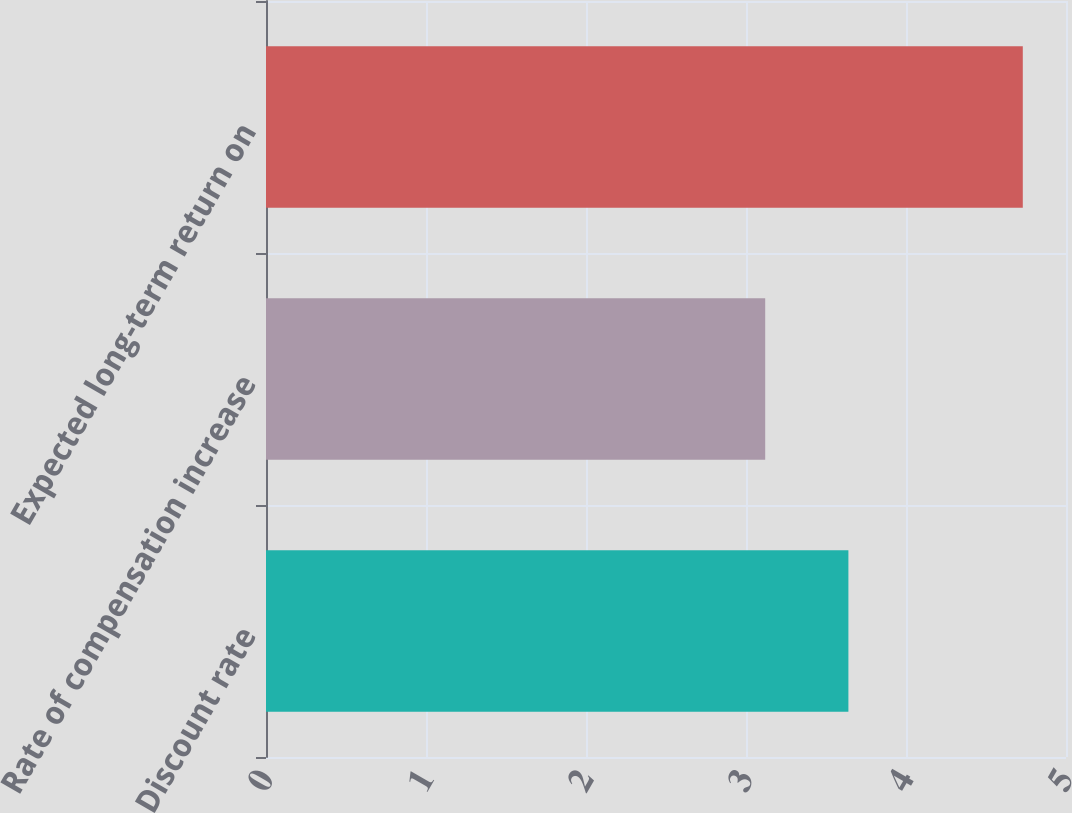<chart> <loc_0><loc_0><loc_500><loc_500><bar_chart><fcel>Discount rate<fcel>Rate of compensation increase<fcel>Expected long-term return on<nl><fcel>3.64<fcel>3.12<fcel>4.73<nl></chart> 